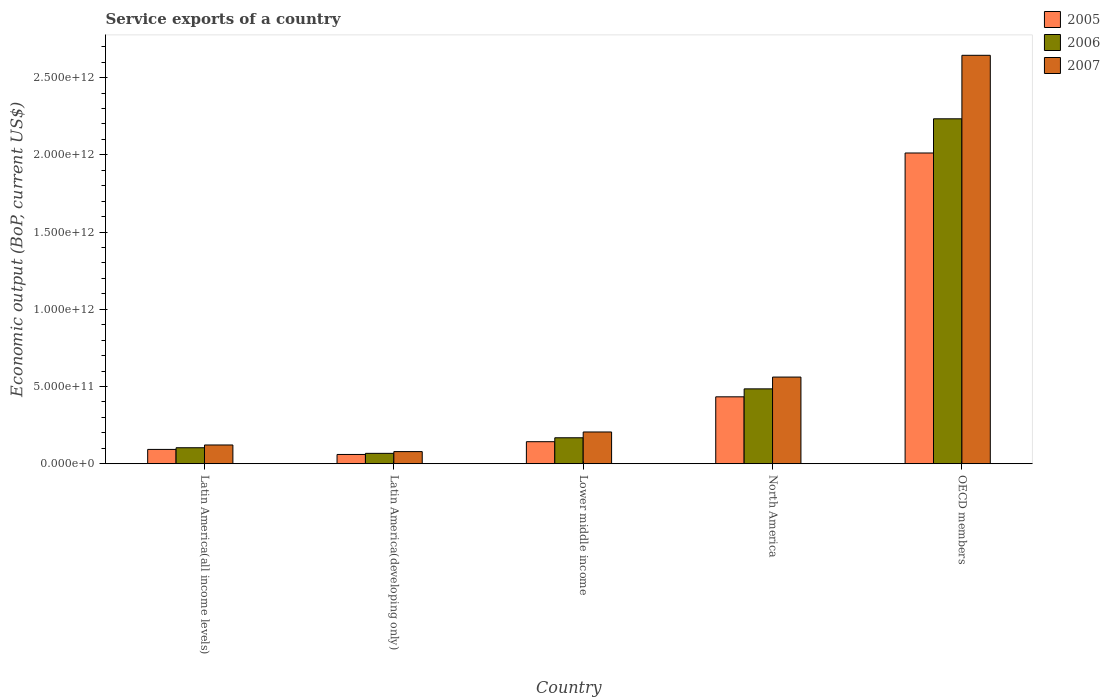How many groups of bars are there?
Your answer should be very brief. 5. Are the number of bars on each tick of the X-axis equal?
Ensure brevity in your answer.  Yes. How many bars are there on the 5th tick from the left?
Offer a terse response. 3. What is the service exports in 2007 in Latin America(all income levels)?
Give a very brief answer. 1.21e+11. Across all countries, what is the maximum service exports in 2007?
Provide a succinct answer. 2.64e+12. Across all countries, what is the minimum service exports in 2007?
Provide a succinct answer. 7.86e+1. In which country was the service exports in 2005 minimum?
Your answer should be very brief. Latin America(developing only). What is the total service exports in 2005 in the graph?
Give a very brief answer. 2.74e+12. What is the difference between the service exports in 2006 in Latin America(all income levels) and that in North America?
Your response must be concise. -3.81e+11. What is the difference between the service exports in 2005 in Latin America(developing only) and the service exports in 2006 in Lower middle income?
Make the answer very short. -1.08e+11. What is the average service exports in 2005 per country?
Offer a terse response. 5.48e+11. What is the difference between the service exports of/in 2005 and service exports of/in 2007 in Latin America(developing only)?
Your answer should be compact. -1.86e+1. What is the ratio of the service exports in 2007 in Latin America(developing only) to that in Lower middle income?
Your answer should be very brief. 0.38. Is the difference between the service exports in 2005 in Latin America(developing only) and Lower middle income greater than the difference between the service exports in 2007 in Latin America(developing only) and Lower middle income?
Give a very brief answer. Yes. What is the difference between the highest and the second highest service exports in 2006?
Your answer should be very brief. 3.17e+11. What is the difference between the highest and the lowest service exports in 2005?
Offer a very short reply. 1.95e+12. Is the sum of the service exports in 2007 in Latin America(all income levels) and North America greater than the maximum service exports in 2005 across all countries?
Make the answer very short. No. What does the 1st bar from the left in North America represents?
Make the answer very short. 2005. How many bars are there?
Keep it short and to the point. 15. What is the difference between two consecutive major ticks on the Y-axis?
Your response must be concise. 5.00e+11. Does the graph contain any zero values?
Your answer should be very brief. No. Does the graph contain grids?
Offer a terse response. No. Where does the legend appear in the graph?
Offer a very short reply. Top right. How many legend labels are there?
Your answer should be compact. 3. How are the legend labels stacked?
Your answer should be very brief. Vertical. What is the title of the graph?
Offer a very short reply. Service exports of a country. What is the label or title of the X-axis?
Offer a very short reply. Country. What is the label or title of the Y-axis?
Ensure brevity in your answer.  Economic output (BoP, current US$). What is the Economic output (BoP, current US$) in 2005 in Latin America(all income levels)?
Offer a very short reply. 9.28e+1. What is the Economic output (BoP, current US$) in 2006 in Latin America(all income levels)?
Ensure brevity in your answer.  1.04e+11. What is the Economic output (BoP, current US$) in 2007 in Latin America(all income levels)?
Offer a very short reply. 1.21e+11. What is the Economic output (BoP, current US$) of 2005 in Latin America(developing only)?
Make the answer very short. 6.00e+1. What is the Economic output (BoP, current US$) in 2006 in Latin America(developing only)?
Offer a terse response. 6.73e+1. What is the Economic output (BoP, current US$) in 2007 in Latin America(developing only)?
Your answer should be very brief. 7.86e+1. What is the Economic output (BoP, current US$) of 2005 in Lower middle income?
Offer a very short reply. 1.43e+11. What is the Economic output (BoP, current US$) in 2006 in Lower middle income?
Give a very brief answer. 1.68e+11. What is the Economic output (BoP, current US$) in 2007 in Lower middle income?
Offer a very short reply. 2.06e+11. What is the Economic output (BoP, current US$) of 2005 in North America?
Make the answer very short. 4.33e+11. What is the Economic output (BoP, current US$) in 2006 in North America?
Give a very brief answer. 4.85e+11. What is the Economic output (BoP, current US$) of 2007 in North America?
Make the answer very short. 5.61e+11. What is the Economic output (BoP, current US$) of 2005 in OECD members?
Your answer should be very brief. 2.01e+12. What is the Economic output (BoP, current US$) of 2006 in OECD members?
Your answer should be compact. 2.23e+12. What is the Economic output (BoP, current US$) of 2007 in OECD members?
Ensure brevity in your answer.  2.64e+12. Across all countries, what is the maximum Economic output (BoP, current US$) in 2005?
Your response must be concise. 2.01e+12. Across all countries, what is the maximum Economic output (BoP, current US$) in 2006?
Make the answer very short. 2.23e+12. Across all countries, what is the maximum Economic output (BoP, current US$) in 2007?
Give a very brief answer. 2.64e+12. Across all countries, what is the minimum Economic output (BoP, current US$) in 2005?
Your response must be concise. 6.00e+1. Across all countries, what is the minimum Economic output (BoP, current US$) in 2006?
Provide a short and direct response. 6.73e+1. Across all countries, what is the minimum Economic output (BoP, current US$) of 2007?
Keep it short and to the point. 7.86e+1. What is the total Economic output (BoP, current US$) in 2005 in the graph?
Make the answer very short. 2.74e+12. What is the total Economic output (BoP, current US$) of 2006 in the graph?
Your answer should be very brief. 3.06e+12. What is the total Economic output (BoP, current US$) in 2007 in the graph?
Provide a succinct answer. 3.61e+12. What is the difference between the Economic output (BoP, current US$) in 2005 in Latin America(all income levels) and that in Latin America(developing only)?
Provide a short and direct response. 3.27e+1. What is the difference between the Economic output (BoP, current US$) of 2006 in Latin America(all income levels) and that in Latin America(developing only)?
Make the answer very short. 3.62e+1. What is the difference between the Economic output (BoP, current US$) of 2007 in Latin America(all income levels) and that in Latin America(developing only)?
Ensure brevity in your answer.  4.29e+1. What is the difference between the Economic output (BoP, current US$) in 2005 in Latin America(all income levels) and that in Lower middle income?
Give a very brief answer. -4.99e+1. What is the difference between the Economic output (BoP, current US$) in 2006 in Latin America(all income levels) and that in Lower middle income?
Make the answer very short. -6.46e+1. What is the difference between the Economic output (BoP, current US$) in 2007 in Latin America(all income levels) and that in Lower middle income?
Keep it short and to the point. -8.42e+1. What is the difference between the Economic output (BoP, current US$) of 2005 in Latin America(all income levels) and that in North America?
Provide a short and direct response. -3.41e+11. What is the difference between the Economic output (BoP, current US$) of 2006 in Latin America(all income levels) and that in North America?
Your answer should be very brief. -3.81e+11. What is the difference between the Economic output (BoP, current US$) in 2007 in Latin America(all income levels) and that in North America?
Offer a very short reply. -4.40e+11. What is the difference between the Economic output (BoP, current US$) of 2005 in Latin America(all income levels) and that in OECD members?
Offer a very short reply. -1.92e+12. What is the difference between the Economic output (BoP, current US$) in 2006 in Latin America(all income levels) and that in OECD members?
Provide a short and direct response. -2.13e+12. What is the difference between the Economic output (BoP, current US$) in 2007 in Latin America(all income levels) and that in OECD members?
Offer a very short reply. -2.52e+12. What is the difference between the Economic output (BoP, current US$) of 2005 in Latin America(developing only) and that in Lower middle income?
Offer a terse response. -8.27e+1. What is the difference between the Economic output (BoP, current US$) in 2006 in Latin America(developing only) and that in Lower middle income?
Ensure brevity in your answer.  -1.01e+11. What is the difference between the Economic output (BoP, current US$) in 2007 in Latin America(developing only) and that in Lower middle income?
Offer a very short reply. -1.27e+11. What is the difference between the Economic output (BoP, current US$) in 2005 in Latin America(developing only) and that in North America?
Provide a short and direct response. -3.73e+11. What is the difference between the Economic output (BoP, current US$) of 2006 in Latin America(developing only) and that in North America?
Offer a very short reply. -4.17e+11. What is the difference between the Economic output (BoP, current US$) of 2007 in Latin America(developing only) and that in North America?
Your response must be concise. -4.83e+11. What is the difference between the Economic output (BoP, current US$) of 2005 in Latin America(developing only) and that in OECD members?
Give a very brief answer. -1.95e+12. What is the difference between the Economic output (BoP, current US$) of 2006 in Latin America(developing only) and that in OECD members?
Your answer should be very brief. -2.17e+12. What is the difference between the Economic output (BoP, current US$) of 2007 in Latin America(developing only) and that in OECD members?
Provide a succinct answer. -2.57e+12. What is the difference between the Economic output (BoP, current US$) in 2005 in Lower middle income and that in North America?
Ensure brevity in your answer.  -2.91e+11. What is the difference between the Economic output (BoP, current US$) in 2006 in Lower middle income and that in North America?
Make the answer very short. -3.17e+11. What is the difference between the Economic output (BoP, current US$) of 2007 in Lower middle income and that in North America?
Ensure brevity in your answer.  -3.56e+11. What is the difference between the Economic output (BoP, current US$) of 2005 in Lower middle income and that in OECD members?
Your answer should be compact. -1.87e+12. What is the difference between the Economic output (BoP, current US$) in 2006 in Lower middle income and that in OECD members?
Your response must be concise. -2.07e+12. What is the difference between the Economic output (BoP, current US$) in 2007 in Lower middle income and that in OECD members?
Your response must be concise. -2.44e+12. What is the difference between the Economic output (BoP, current US$) in 2005 in North America and that in OECD members?
Provide a succinct answer. -1.58e+12. What is the difference between the Economic output (BoP, current US$) in 2006 in North America and that in OECD members?
Your response must be concise. -1.75e+12. What is the difference between the Economic output (BoP, current US$) in 2007 in North America and that in OECD members?
Provide a short and direct response. -2.08e+12. What is the difference between the Economic output (BoP, current US$) of 2005 in Latin America(all income levels) and the Economic output (BoP, current US$) of 2006 in Latin America(developing only)?
Give a very brief answer. 2.55e+1. What is the difference between the Economic output (BoP, current US$) of 2005 in Latin America(all income levels) and the Economic output (BoP, current US$) of 2007 in Latin America(developing only)?
Keep it short and to the point. 1.42e+1. What is the difference between the Economic output (BoP, current US$) in 2006 in Latin America(all income levels) and the Economic output (BoP, current US$) in 2007 in Latin America(developing only)?
Ensure brevity in your answer.  2.50e+1. What is the difference between the Economic output (BoP, current US$) in 2005 in Latin America(all income levels) and the Economic output (BoP, current US$) in 2006 in Lower middle income?
Offer a very short reply. -7.54e+1. What is the difference between the Economic output (BoP, current US$) of 2005 in Latin America(all income levels) and the Economic output (BoP, current US$) of 2007 in Lower middle income?
Offer a terse response. -1.13e+11. What is the difference between the Economic output (BoP, current US$) of 2006 in Latin America(all income levels) and the Economic output (BoP, current US$) of 2007 in Lower middle income?
Keep it short and to the point. -1.02e+11. What is the difference between the Economic output (BoP, current US$) in 2005 in Latin America(all income levels) and the Economic output (BoP, current US$) in 2006 in North America?
Provide a short and direct response. -3.92e+11. What is the difference between the Economic output (BoP, current US$) of 2005 in Latin America(all income levels) and the Economic output (BoP, current US$) of 2007 in North America?
Your answer should be compact. -4.68e+11. What is the difference between the Economic output (BoP, current US$) in 2006 in Latin America(all income levels) and the Economic output (BoP, current US$) in 2007 in North America?
Keep it short and to the point. -4.58e+11. What is the difference between the Economic output (BoP, current US$) of 2005 in Latin America(all income levels) and the Economic output (BoP, current US$) of 2006 in OECD members?
Ensure brevity in your answer.  -2.14e+12. What is the difference between the Economic output (BoP, current US$) in 2005 in Latin America(all income levels) and the Economic output (BoP, current US$) in 2007 in OECD members?
Make the answer very short. -2.55e+12. What is the difference between the Economic output (BoP, current US$) in 2006 in Latin America(all income levels) and the Economic output (BoP, current US$) in 2007 in OECD members?
Keep it short and to the point. -2.54e+12. What is the difference between the Economic output (BoP, current US$) of 2005 in Latin America(developing only) and the Economic output (BoP, current US$) of 2006 in Lower middle income?
Offer a very short reply. -1.08e+11. What is the difference between the Economic output (BoP, current US$) of 2005 in Latin America(developing only) and the Economic output (BoP, current US$) of 2007 in Lower middle income?
Ensure brevity in your answer.  -1.46e+11. What is the difference between the Economic output (BoP, current US$) of 2006 in Latin America(developing only) and the Economic output (BoP, current US$) of 2007 in Lower middle income?
Give a very brief answer. -1.38e+11. What is the difference between the Economic output (BoP, current US$) of 2005 in Latin America(developing only) and the Economic output (BoP, current US$) of 2006 in North America?
Your answer should be very brief. -4.25e+11. What is the difference between the Economic output (BoP, current US$) of 2005 in Latin America(developing only) and the Economic output (BoP, current US$) of 2007 in North America?
Offer a very short reply. -5.01e+11. What is the difference between the Economic output (BoP, current US$) in 2006 in Latin America(developing only) and the Economic output (BoP, current US$) in 2007 in North America?
Offer a very short reply. -4.94e+11. What is the difference between the Economic output (BoP, current US$) in 2005 in Latin America(developing only) and the Economic output (BoP, current US$) in 2006 in OECD members?
Make the answer very short. -2.17e+12. What is the difference between the Economic output (BoP, current US$) in 2005 in Latin America(developing only) and the Economic output (BoP, current US$) in 2007 in OECD members?
Your answer should be very brief. -2.58e+12. What is the difference between the Economic output (BoP, current US$) of 2006 in Latin America(developing only) and the Economic output (BoP, current US$) of 2007 in OECD members?
Keep it short and to the point. -2.58e+12. What is the difference between the Economic output (BoP, current US$) in 2005 in Lower middle income and the Economic output (BoP, current US$) in 2006 in North America?
Your answer should be compact. -3.42e+11. What is the difference between the Economic output (BoP, current US$) in 2005 in Lower middle income and the Economic output (BoP, current US$) in 2007 in North America?
Your answer should be very brief. -4.18e+11. What is the difference between the Economic output (BoP, current US$) in 2006 in Lower middle income and the Economic output (BoP, current US$) in 2007 in North America?
Keep it short and to the point. -3.93e+11. What is the difference between the Economic output (BoP, current US$) of 2005 in Lower middle income and the Economic output (BoP, current US$) of 2006 in OECD members?
Provide a short and direct response. -2.09e+12. What is the difference between the Economic output (BoP, current US$) of 2005 in Lower middle income and the Economic output (BoP, current US$) of 2007 in OECD members?
Keep it short and to the point. -2.50e+12. What is the difference between the Economic output (BoP, current US$) of 2006 in Lower middle income and the Economic output (BoP, current US$) of 2007 in OECD members?
Offer a terse response. -2.48e+12. What is the difference between the Economic output (BoP, current US$) in 2005 in North America and the Economic output (BoP, current US$) in 2006 in OECD members?
Keep it short and to the point. -1.80e+12. What is the difference between the Economic output (BoP, current US$) in 2005 in North America and the Economic output (BoP, current US$) in 2007 in OECD members?
Your response must be concise. -2.21e+12. What is the difference between the Economic output (BoP, current US$) in 2006 in North America and the Economic output (BoP, current US$) in 2007 in OECD members?
Keep it short and to the point. -2.16e+12. What is the average Economic output (BoP, current US$) of 2005 per country?
Provide a short and direct response. 5.48e+11. What is the average Economic output (BoP, current US$) in 2006 per country?
Provide a short and direct response. 6.11e+11. What is the average Economic output (BoP, current US$) in 2007 per country?
Provide a succinct answer. 7.22e+11. What is the difference between the Economic output (BoP, current US$) in 2005 and Economic output (BoP, current US$) in 2006 in Latin America(all income levels)?
Your answer should be very brief. -1.08e+1. What is the difference between the Economic output (BoP, current US$) of 2005 and Economic output (BoP, current US$) of 2007 in Latin America(all income levels)?
Ensure brevity in your answer.  -2.87e+1. What is the difference between the Economic output (BoP, current US$) in 2006 and Economic output (BoP, current US$) in 2007 in Latin America(all income levels)?
Your response must be concise. -1.79e+1. What is the difference between the Economic output (BoP, current US$) of 2005 and Economic output (BoP, current US$) of 2006 in Latin America(developing only)?
Give a very brief answer. -7.28e+09. What is the difference between the Economic output (BoP, current US$) in 2005 and Economic output (BoP, current US$) in 2007 in Latin America(developing only)?
Offer a terse response. -1.86e+1. What is the difference between the Economic output (BoP, current US$) in 2006 and Economic output (BoP, current US$) in 2007 in Latin America(developing only)?
Make the answer very short. -1.13e+1. What is the difference between the Economic output (BoP, current US$) in 2005 and Economic output (BoP, current US$) in 2006 in Lower middle income?
Your answer should be very brief. -2.54e+1. What is the difference between the Economic output (BoP, current US$) of 2005 and Economic output (BoP, current US$) of 2007 in Lower middle income?
Provide a succinct answer. -6.29e+1. What is the difference between the Economic output (BoP, current US$) in 2006 and Economic output (BoP, current US$) in 2007 in Lower middle income?
Keep it short and to the point. -3.75e+1. What is the difference between the Economic output (BoP, current US$) in 2005 and Economic output (BoP, current US$) in 2006 in North America?
Provide a short and direct response. -5.14e+1. What is the difference between the Economic output (BoP, current US$) of 2005 and Economic output (BoP, current US$) of 2007 in North America?
Offer a very short reply. -1.28e+11. What is the difference between the Economic output (BoP, current US$) in 2006 and Economic output (BoP, current US$) in 2007 in North America?
Give a very brief answer. -7.64e+1. What is the difference between the Economic output (BoP, current US$) of 2005 and Economic output (BoP, current US$) of 2006 in OECD members?
Your response must be concise. -2.21e+11. What is the difference between the Economic output (BoP, current US$) in 2005 and Economic output (BoP, current US$) in 2007 in OECD members?
Make the answer very short. -6.33e+11. What is the difference between the Economic output (BoP, current US$) of 2006 and Economic output (BoP, current US$) of 2007 in OECD members?
Offer a very short reply. -4.11e+11. What is the ratio of the Economic output (BoP, current US$) of 2005 in Latin America(all income levels) to that in Latin America(developing only)?
Your answer should be compact. 1.55. What is the ratio of the Economic output (BoP, current US$) in 2006 in Latin America(all income levels) to that in Latin America(developing only)?
Your response must be concise. 1.54. What is the ratio of the Economic output (BoP, current US$) in 2007 in Latin America(all income levels) to that in Latin America(developing only)?
Your response must be concise. 1.55. What is the ratio of the Economic output (BoP, current US$) in 2005 in Latin America(all income levels) to that in Lower middle income?
Offer a terse response. 0.65. What is the ratio of the Economic output (BoP, current US$) of 2006 in Latin America(all income levels) to that in Lower middle income?
Your answer should be very brief. 0.62. What is the ratio of the Economic output (BoP, current US$) of 2007 in Latin America(all income levels) to that in Lower middle income?
Provide a short and direct response. 0.59. What is the ratio of the Economic output (BoP, current US$) of 2005 in Latin America(all income levels) to that in North America?
Give a very brief answer. 0.21. What is the ratio of the Economic output (BoP, current US$) in 2006 in Latin America(all income levels) to that in North America?
Your answer should be very brief. 0.21. What is the ratio of the Economic output (BoP, current US$) in 2007 in Latin America(all income levels) to that in North America?
Offer a terse response. 0.22. What is the ratio of the Economic output (BoP, current US$) of 2005 in Latin America(all income levels) to that in OECD members?
Make the answer very short. 0.05. What is the ratio of the Economic output (BoP, current US$) of 2006 in Latin America(all income levels) to that in OECD members?
Keep it short and to the point. 0.05. What is the ratio of the Economic output (BoP, current US$) of 2007 in Latin America(all income levels) to that in OECD members?
Give a very brief answer. 0.05. What is the ratio of the Economic output (BoP, current US$) in 2005 in Latin America(developing only) to that in Lower middle income?
Ensure brevity in your answer.  0.42. What is the ratio of the Economic output (BoP, current US$) of 2006 in Latin America(developing only) to that in Lower middle income?
Make the answer very short. 0.4. What is the ratio of the Economic output (BoP, current US$) of 2007 in Latin America(developing only) to that in Lower middle income?
Make the answer very short. 0.38. What is the ratio of the Economic output (BoP, current US$) in 2005 in Latin America(developing only) to that in North America?
Offer a terse response. 0.14. What is the ratio of the Economic output (BoP, current US$) in 2006 in Latin America(developing only) to that in North America?
Provide a succinct answer. 0.14. What is the ratio of the Economic output (BoP, current US$) of 2007 in Latin America(developing only) to that in North America?
Offer a terse response. 0.14. What is the ratio of the Economic output (BoP, current US$) of 2005 in Latin America(developing only) to that in OECD members?
Your response must be concise. 0.03. What is the ratio of the Economic output (BoP, current US$) of 2006 in Latin America(developing only) to that in OECD members?
Give a very brief answer. 0.03. What is the ratio of the Economic output (BoP, current US$) of 2007 in Latin America(developing only) to that in OECD members?
Your answer should be very brief. 0.03. What is the ratio of the Economic output (BoP, current US$) of 2005 in Lower middle income to that in North America?
Offer a very short reply. 0.33. What is the ratio of the Economic output (BoP, current US$) of 2006 in Lower middle income to that in North America?
Your answer should be compact. 0.35. What is the ratio of the Economic output (BoP, current US$) in 2007 in Lower middle income to that in North America?
Your response must be concise. 0.37. What is the ratio of the Economic output (BoP, current US$) of 2005 in Lower middle income to that in OECD members?
Keep it short and to the point. 0.07. What is the ratio of the Economic output (BoP, current US$) of 2006 in Lower middle income to that in OECD members?
Your answer should be compact. 0.08. What is the ratio of the Economic output (BoP, current US$) in 2007 in Lower middle income to that in OECD members?
Your answer should be compact. 0.08. What is the ratio of the Economic output (BoP, current US$) in 2005 in North America to that in OECD members?
Offer a very short reply. 0.22. What is the ratio of the Economic output (BoP, current US$) of 2006 in North America to that in OECD members?
Provide a short and direct response. 0.22. What is the ratio of the Economic output (BoP, current US$) of 2007 in North America to that in OECD members?
Provide a short and direct response. 0.21. What is the difference between the highest and the second highest Economic output (BoP, current US$) in 2005?
Your answer should be compact. 1.58e+12. What is the difference between the highest and the second highest Economic output (BoP, current US$) of 2006?
Give a very brief answer. 1.75e+12. What is the difference between the highest and the second highest Economic output (BoP, current US$) in 2007?
Offer a terse response. 2.08e+12. What is the difference between the highest and the lowest Economic output (BoP, current US$) of 2005?
Offer a terse response. 1.95e+12. What is the difference between the highest and the lowest Economic output (BoP, current US$) of 2006?
Give a very brief answer. 2.17e+12. What is the difference between the highest and the lowest Economic output (BoP, current US$) in 2007?
Your answer should be very brief. 2.57e+12. 